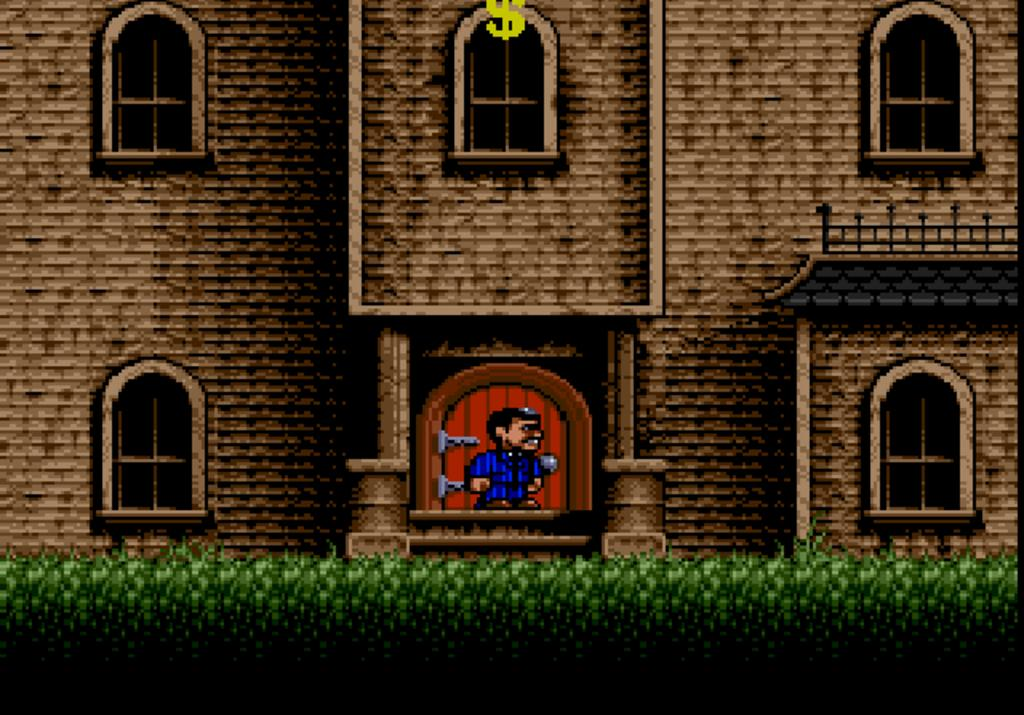What type of image is being described? The image is an animation. What is the main structure in the image? There is a building in the middle of the image. What is located in front of the building? There are plants in front of the building. Can you describe the person in the image? There is a person standing in front of the door of the building. What type of brush is the person using to paint the flag in the image? There is no brush or flag present in the image; it features an animation of a building with plants and a person standing in front of the door. 